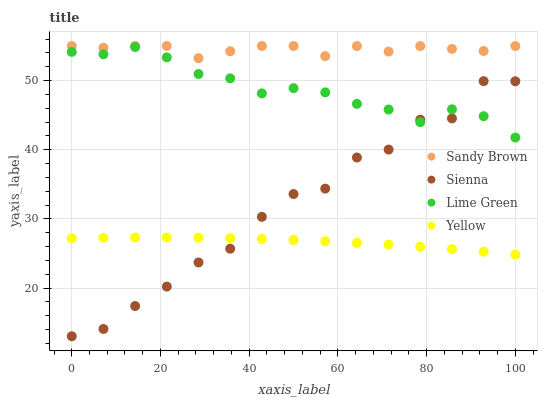Does Yellow have the minimum area under the curve?
Answer yes or no. Yes. Does Sandy Brown have the maximum area under the curve?
Answer yes or no. Yes. Does Lime Green have the minimum area under the curve?
Answer yes or no. No. Does Lime Green have the maximum area under the curve?
Answer yes or no. No. Is Yellow the smoothest?
Answer yes or no. Yes. Is Sienna the roughest?
Answer yes or no. Yes. Is Lime Green the smoothest?
Answer yes or no. No. Is Lime Green the roughest?
Answer yes or no. No. Does Sienna have the lowest value?
Answer yes or no. Yes. Does Lime Green have the lowest value?
Answer yes or no. No. Does Sandy Brown have the highest value?
Answer yes or no. Yes. Does Lime Green have the highest value?
Answer yes or no. No. Is Yellow less than Lime Green?
Answer yes or no. Yes. Is Sandy Brown greater than Sienna?
Answer yes or no. Yes. Does Lime Green intersect Sienna?
Answer yes or no. Yes. Is Lime Green less than Sienna?
Answer yes or no. No. Is Lime Green greater than Sienna?
Answer yes or no. No. Does Yellow intersect Lime Green?
Answer yes or no. No. 